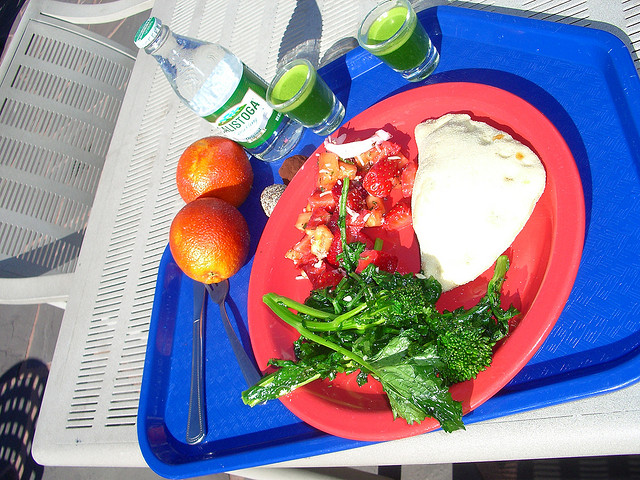Please transcribe the text in this image. STO ALISTOGA 